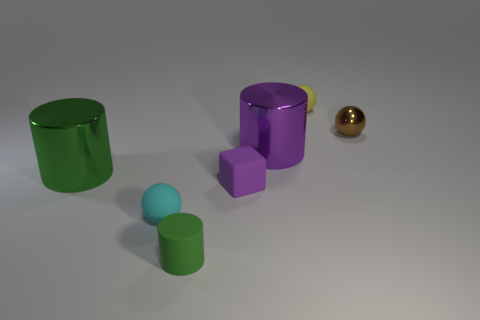There is a large thing that is the same color as the tiny block; what shape is it?
Your answer should be very brief. Cylinder. Are there any other things that are the same color as the small cylinder?
Provide a short and direct response. Yes. Is there a metal cylinder behind the metallic thing on the left side of the green matte thing?
Provide a short and direct response. Yes. Are there any tiny blue matte objects that have the same shape as the yellow rubber object?
Provide a succinct answer. No. How many metal things are left of the tiny matte object behind the shiny thing that is on the right side of the small yellow matte sphere?
Offer a terse response. 2. Do the tiny cylinder and the large object that is to the left of the small rubber cylinder have the same color?
Keep it short and to the point. Yes. What number of objects are either balls that are behind the big green cylinder or tiny green objects that are in front of the purple cube?
Make the answer very short. 3. Is the number of tiny matte objects that are to the left of the tiny rubber cylinder greater than the number of small brown shiny objects behind the small yellow sphere?
Provide a short and direct response. Yes. What material is the thing that is to the left of the rubber ball on the left side of the matte ball behind the big green object made of?
Keep it short and to the point. Metal. Do the rubber thing that is on the right side of the tiny block and the purple thing behind the large green cylinder have the same shape?
Your answer should be very brief. No. 